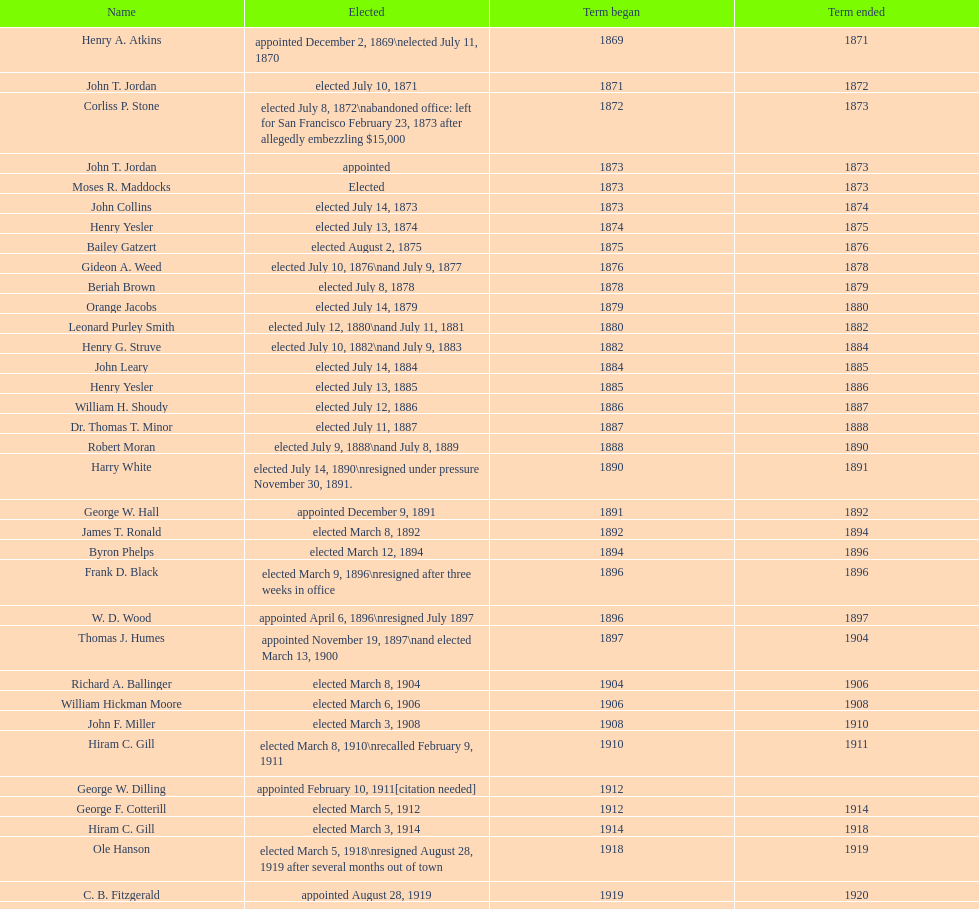For how many days was robert moran in service? 365. 